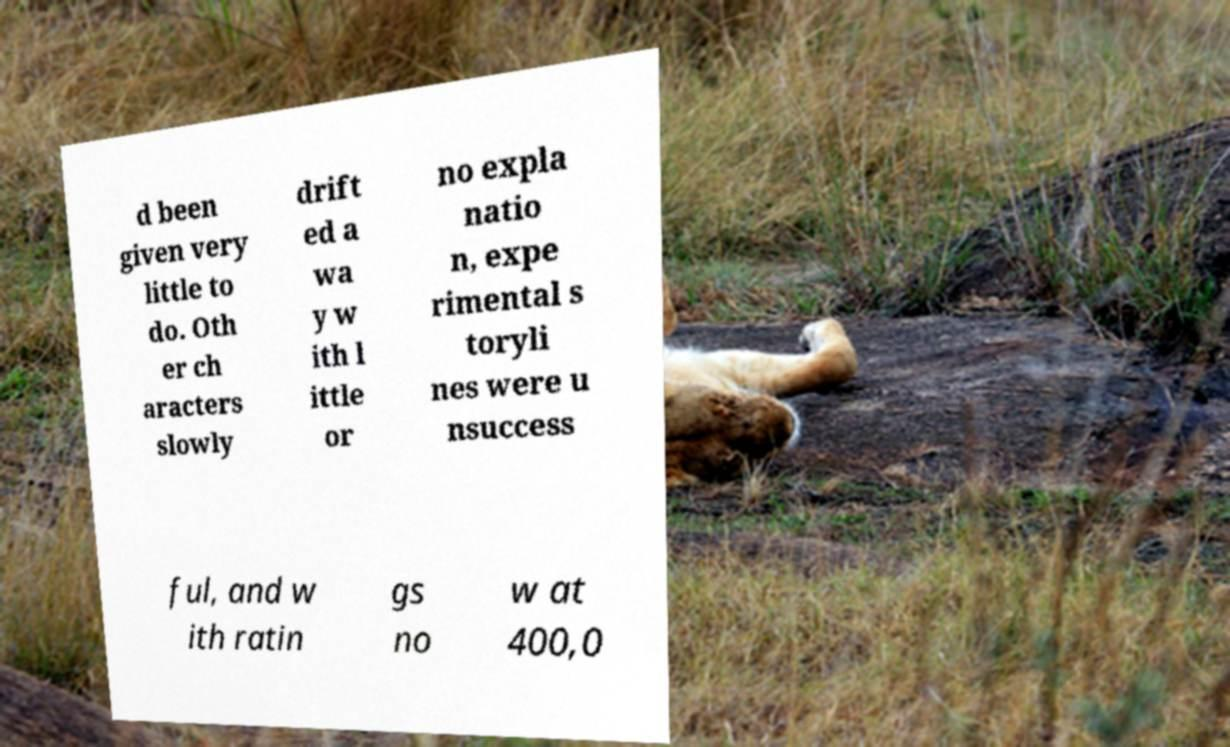There's text embedded in this image that I need extracted. Can you transcribe it verbatim? d been given very little to do. Oth er ch aracters slowly drift ed a wa y w ith l ittle or no expla natio n, expe rimental s toryli nes were u nsuccess ful, and w ith ratin gs no w at 400,0 